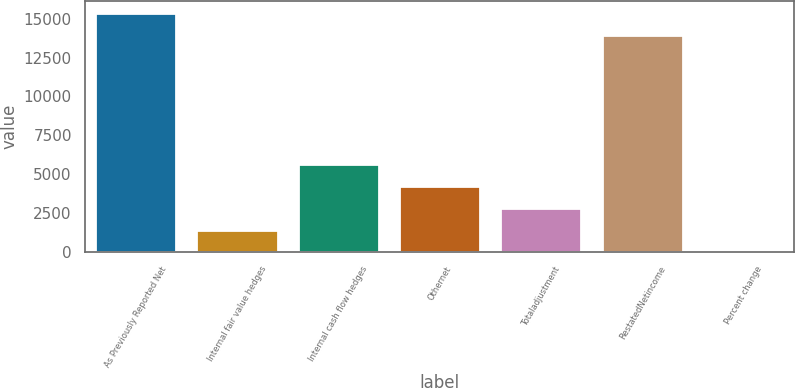Convert chart. <chart><loc_0><loc_0><loc_500><loc_500><bar_chart><fcel>As Previously Reported Net<fcel>Internal fair value hedges<fcel>Internal cash flow hedges<fcel>Othernet<fcel>Totaladjustment<fcel>RestatedNetincome<fcel>Percent change<nl><fcel>15361.2<fcel>1415.56<fcel>5658.04<fcel>4243.88<fcel>2829.72<fcel>13947<fcel>1.4<nl></chart> 